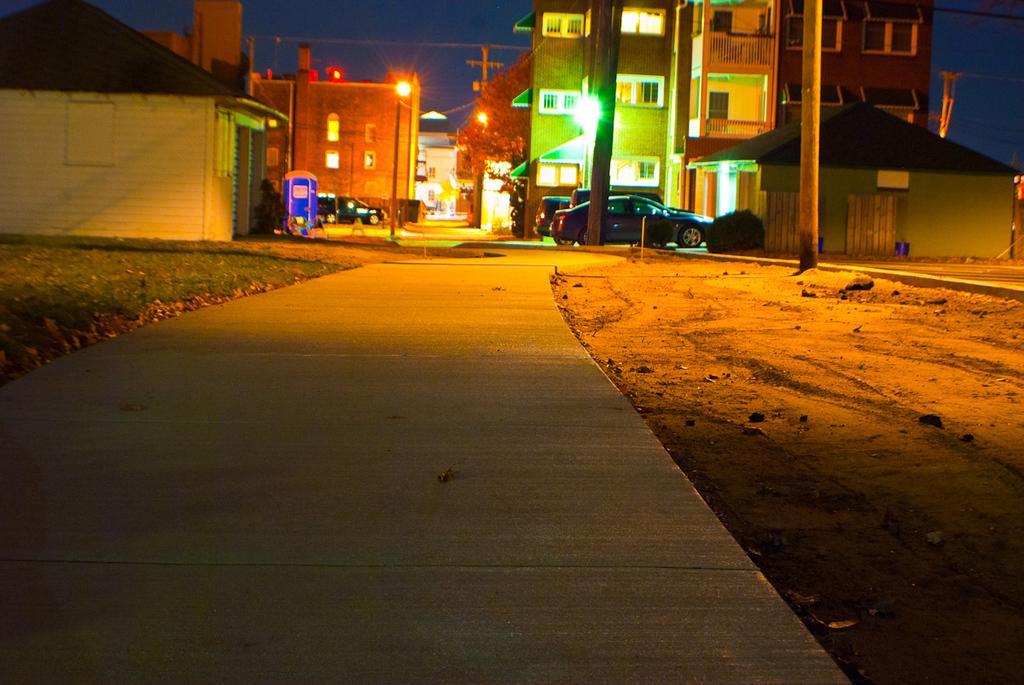In one or two sentences, can you explain what this image depicts? At the top I can see buildings, poles, lights, trees, the sky and vehicles on the road. This image is taken during night. 